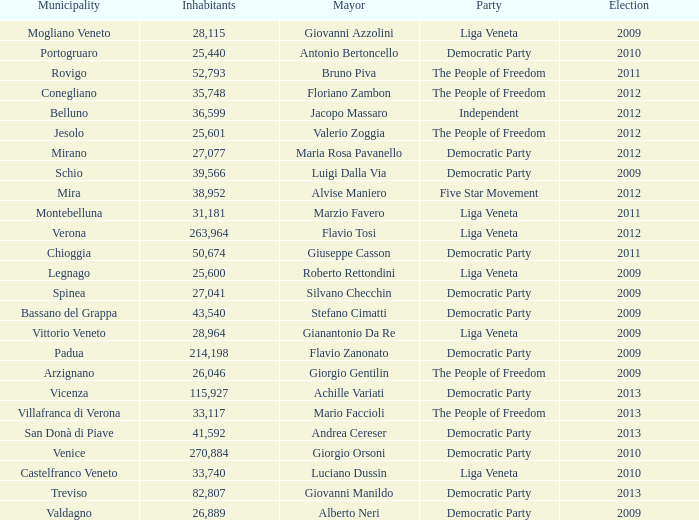How many elections had more than 36,599 inhabitants when Mayor was giovanni manildo? 1.0. 